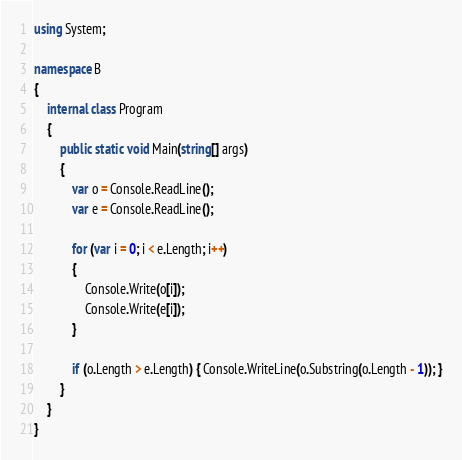Convert code to text. <code><loc_0><loc_0><loc_500><loc_500><_C#_>using System;

namespace B
{
	internal class Program
	{
		public static void Main(string[] args)
		{
			var o = Console.ReadLine();
			var e = Console.ReadLine();

			for (var i = 0; i < e.Length; i++)
			{
				Console.Write(o[i]);
				Console.Write(e[i]);
			}

			if (o.Length > e.Length) { Console.WriteLine(o.Substring(o.Length - 1)); }
		}
	}
}</code> 